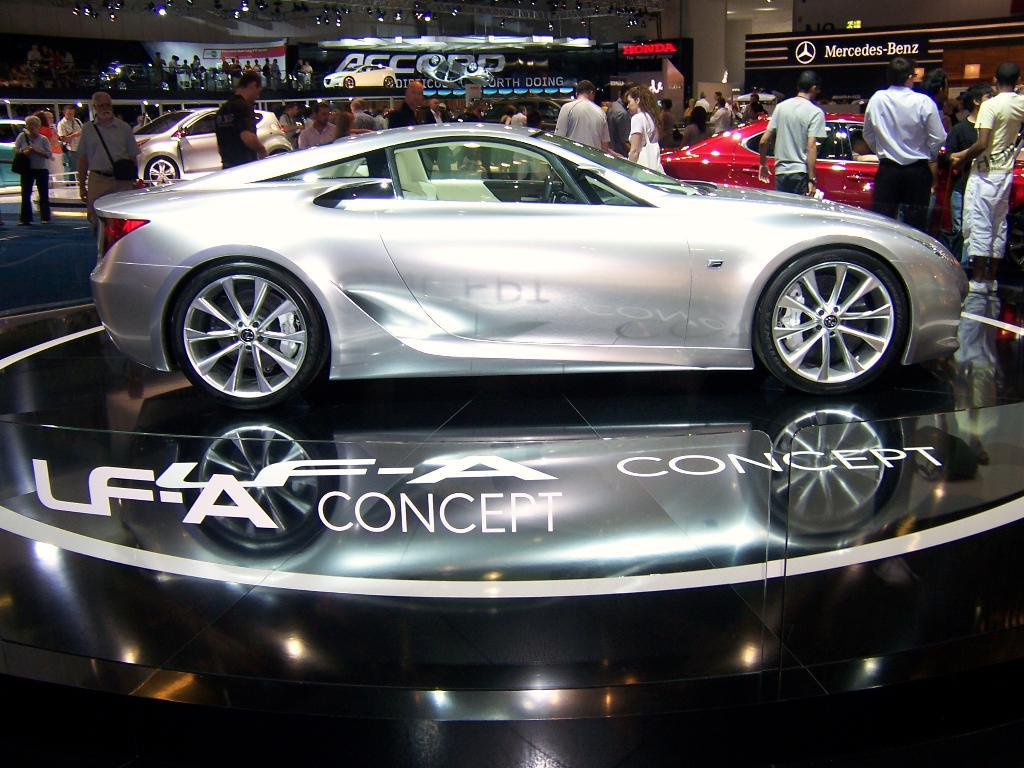What types of objects can be seen in the image? There are vehicles and a group of people standing in the image. What else is visible in the image? There are lights and a lighting truss visible in the image. Are there any other objects present in the image? Yes, there are boards in the image. Can you tell me how many pairs of scissors are being used by the people in the image? There are no scissors present in the image; the people are not using any scissors. What type of soap is being used by the people in the image? There is no soap present in the image; the people are not using any soap. 